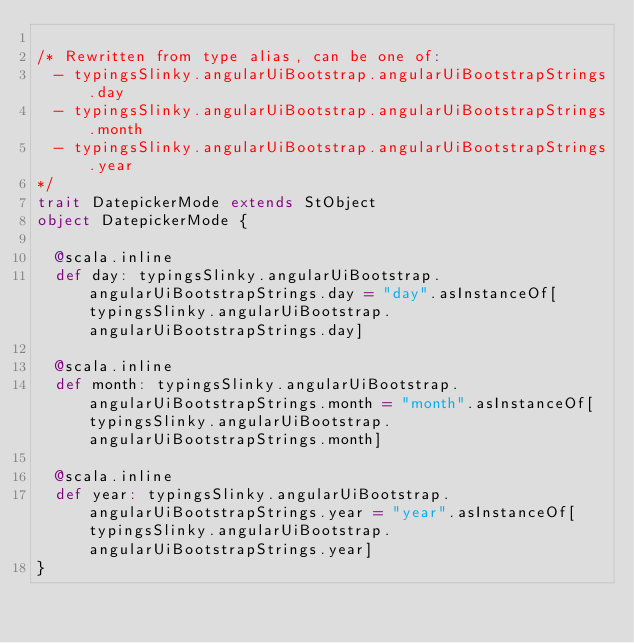<code> <loc_0><loc_0><loc_500><loc_500><_Scala_>
/* Rewritten from type alias, can be one of: 
  - typingsSlinky.angularUiBootstrap.angularUiBootstrapStrings.day
  - typingsSlinky.angularUiBootstrap.angularUiBootstrapStrings.month
  - typingsSlinky.angularUiBootstrap.angularUiBootstrapStrings.year
*/
trait DatepickerMode extends StObject
object DatepickerMode {
  
  @scala.inline
  def day: typingsSlinky.angularUiBootstrap.angularUiBootstrapStrings.day = "day".asInstanceOf[typingsSlinky.angularUiBootstrap.angularUiBootstrapStrings.day]
  
  @scala.inline
  def month: typingsSlinky.angularUiBootstrap.angularUiBootstrapStrings.month = "month".asInstanceOf[typingsSlinky.angularUiBootstrap.angularUiBootstrapStrings.month]
  
  @scala.inline
  def year: typingsSlinky.angularUiBootstrap.angularUiBootstrapStrings.year = "year".asInstanceOf[typingsSlinky.angularUiBootstrap.angularUiBootstrapStrings.year]
}
</code> 